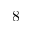<formula> <loc_0><loc_0><loc_500><loc_500>8</formula> 